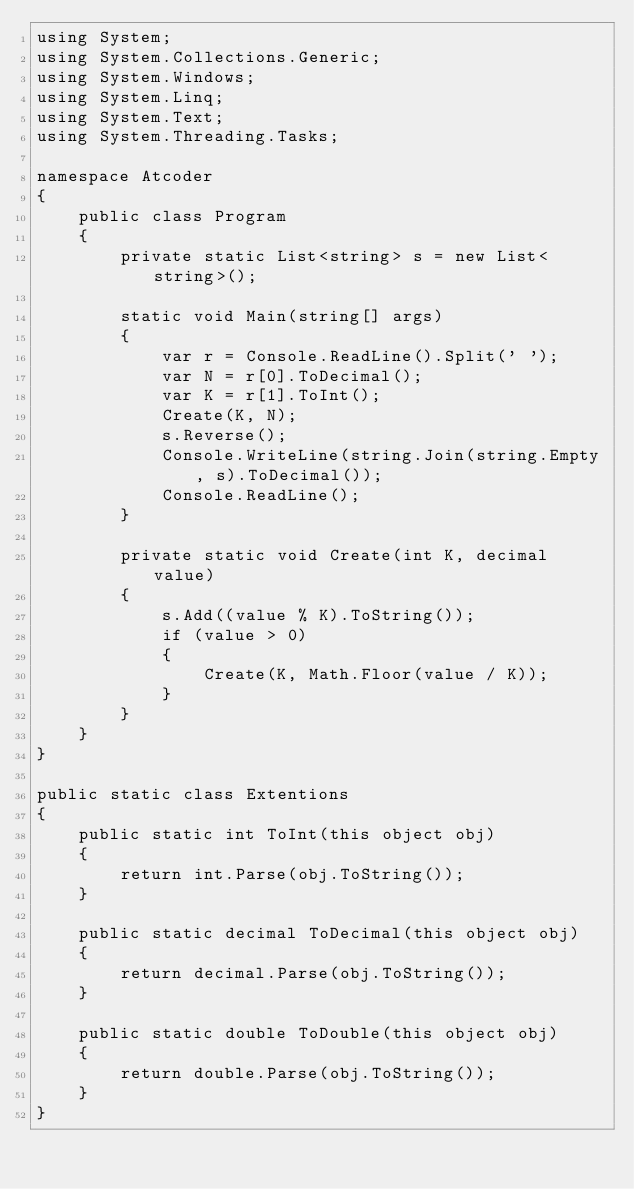<code> <loc_0><loc_0><loc_500><loc_500><_C#_>using System;
using System.Collections.Generic;
using System.Windows;
using System.Linq;
using System.Text;
using System.Threading.Tasks;

namespace Atcoder
{
    public class Program
    {
        private static List<string> s = new List<string>();

        static void Main(string[] args)
        {
            var r = Console.ReadLine().Split(' ');
            var N = r[0].ToDecimal();
            var K = r[1].ToInt();
            Create(K, N);
            s.Reverse();
            Console.WriteLine(string.Join(string.Empty, s).ToDecimal());
            Console.ReadLine();
        }

        private static void Create(int K, decimal value)
        {
            s.Add((value % K).ToString());
            if (value > 0)
            {
                Create(K, Math.Floor(value / K));
            }
        }
    }
}

public static class Extentions
{
    public static int ToInt(this object obj)
    {
        return int.Parse(obj.ToString());
    }

    public static decimal ToDecimal(this object obj)
    {
        return decimal.Parse(obj.ToString());
    }

    public static double ToDouble(this object obj)
    {
        return double.Parse(obj.ToString());
    }
}

</code> 